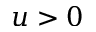<formula> <loc_0><loc_0><loc_500><loc_500>u > 0</formula> 